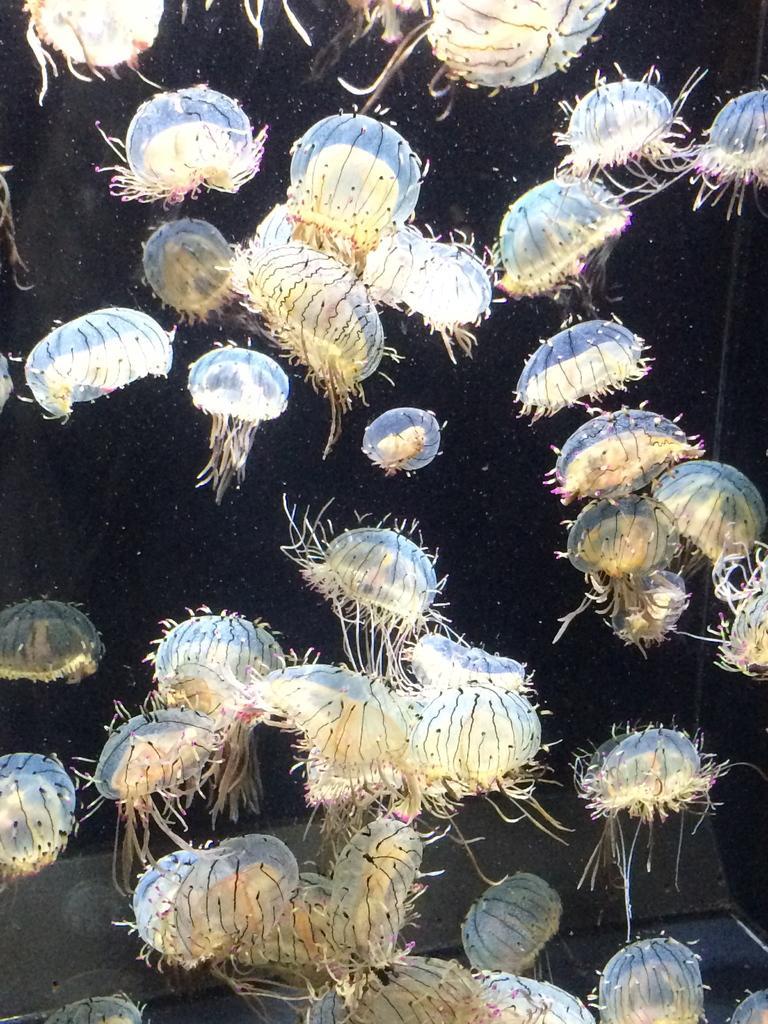In one or two sentences, can you explain what this image depicts? In this image there are water animals. There is black background. 